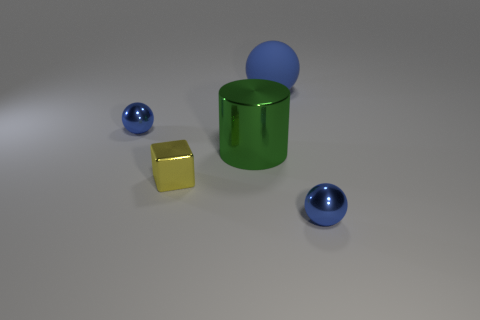What number of other things are there of the same material as the cylinder
Your answer should be compact. 3. What number of matte objects are small brown objects or blue spheres?
Keep it short and to the point. 1. How many things are tiny blue rubber cylinders or large rubber things?
Make the answer very short. 1. There is a big green object that is the same material as the cube; what is its shape?
Your answer should be compact. Cylinder. What number of small objects are green shiny cylinders or cyan cubes?
Ensure brevity in your answer.  0. How many other things are the same color as the metallic block?
Offer a very short reply. 0. What number of tiny blue shiny objects are right of the tiny yellow thing in front of the big blue thing on the right side of the green object?
Your answer should be compact. 1. Do the blue thing in front of the metal cube and the blue rubber thing have the same size?
Your answer should be very brief. No. Are there fewer big shiny cylinders that are to the left of the big green metal object than metal objects behind the tiny block?
Make the answer very short. Yes. Are there fewer big matte things that are to the right of the big sphere than tiny yellow metallic cubes?
Keep it short and to the point. Yes. 